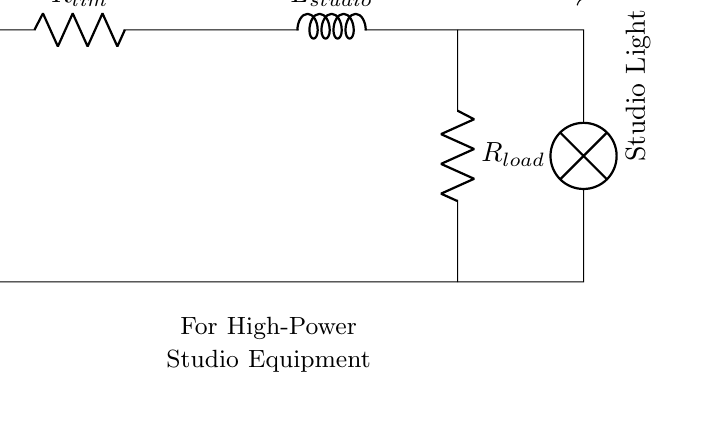What components are in the circuit? The circuit contains a voltage source, two resistors, one inductor, and a lamp. The voltage source provides electrical potential, while the resistors and inductor are part of the inrush current limiting setup, and the lamp indicates load.
Answer: voltage source, resistors, inductor, lamp What is the purpose of the R limiting resistor? The R limiting resistor serves to restrict the initial inrush current when the circuit is powered on, thereby protecting the circuit components from sudden surges. It acts to slow the rate of current increase during start-up.
Answer: restrict inrush current What does the L stand for in this circuit? The L in this circuit represents an inductor, which stores energy in a magnetic field when electric current passes through it. It opposes changes in current, thereby limiting inrush current.
Answer: inductor How does the inductor affect starting current? The inductor limits the rate of change of current when voltage is first applied, causing a gradual increase in current rather than a sharp spike, thereby reducing potential damage from high inrush currents.
Answer: limits current rise What is the role of the lamp connected in this circuit? The lamp acts as a load that visually indicates the circuit’s operation. When the circuit is powered, the lamp lights up, showing that the current is flowing through the circuit and validating its functionality.
Answer: indication of current flow What is the expected energy behavior when the circuit powers on? Upon powering on, initially the inrush current is limited by the resistor, allowing the inductor to gradually build up its magnetic field until the steady-state current is reached, resulting in a smooth energy transition.
Answer: gradual energy increase How does this circuit reduce the risk of damage to studio equipment? By limiting inrush current through the resistor and inductor, the circuit prevents damaging voltage spikes that can occur during power-on, thereby safeguarding sensitive studio equipment from potential overload.
Answer: protects studio equipment 